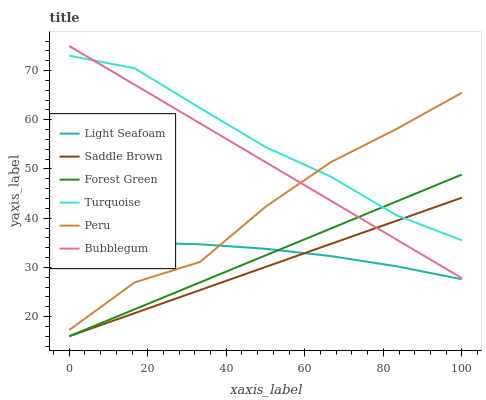Does Saddle Brown have the minimum area under the curve?
Answer yes or no. Yes. Does Turquoise have the maximum area under the curve?
Answer yes or no. Yes. Does Bubblegum have the minimum area under the curve?
Answer yes or no. No. Does Bubblegum have the maximum area under the curve?
Answer yes or no. No. Is Forest Green the smoothest?
Answer yes or no. Yes. Is Peru the roughest?
Answer yes or no. Yes. Is Bubblegum the smoothest?
Answer yes or no. No. Is Bubblegum the roughest?
Answer yes or no. No. Does Forest Green have the lowest value?
Answer yes or no. Yes. Does Bubblegum have the lowest value?
Answer yes or no. No. Does Bubblegum have the highest value?
Answer yes or no. Yes. Does Forest Green have the highest value?
Answer yes or no. No. Is Saddle Brown less than Peru?
Answer yes or no. Yes. Is Turquoise greater than Light Seafoam?
Answer yes or no. Yes. Does Forest Green intersect Saddle Brown?
Answer yes or no. Yes. Is Forest Green less than Saddle Brown?
Answer yes or no. No. Is Forest Green greater than Saddle Brown?
Answer yes or no. No. Does Saddle Brown intersect Peru?
Answer yes or no. No. 